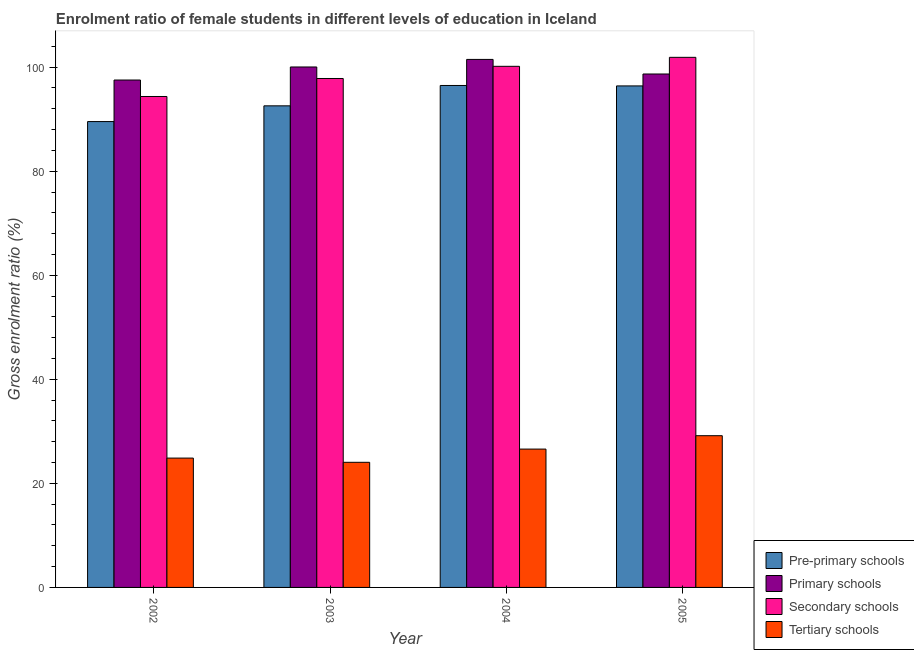How many different coloured bars are there?
Your answer should be very brief. 4. Are the number of bars on each tick of the X-axis equal?
Provide a short and direct response. Yes. How many bars are there on the 1st tick from the left?
Offer a terse response. 4. In how many cases, is the number of bars for a given year not equal to the number of legend labels?
Ensure brevity in your answer.  0. What is the gross enrolment ratio(male) in secondary schools in 2002?
Give a very brief answer. 94.36. Across all years, what is the maximum gross enrolment ratio(male) in pre-primary schools?
Give a very brief answer. 96.48. Across all years, what is the minimum gross enrolment ratio(male) in primary schools?
Your answer should be compact. 97.52. What is the total gross enrolment ratio(male) in secondary schools in the graph?
Offer a terse response. 394.22. What is the difference between the gross enrolment ratio(male) in tertiary schools in 2003 and that in 2004?
Your answer should be compact. -2.54. What is the difference between the gross enrolment ratio(male) in pre-primary schools in 2003 and the gross enrolment ratio(male) in secondary schools in 2002?
Offer a very short reply. 3.02. What is the average gross enrolment ratio(male) in primary schools per year?
Provide a succinct answer. 99.43. In the year 2002, what is the difference between the gross enrolment ratio(male) in primary schools and gross enrolment ratio(male) in tertiary schools?
Ensure brevity in your answer.  0. What is the ratio of the gross enrolment ratio(male) in secondary schools in 2002 to that in 2004?
Make the answer very short. 0.94. Is the difference between the gross enrolment ratio(male) in pre-primary schools in 2004 and 2005 greater than the difference between the gross enrolment ratio(male) in tertiary schools in 2004 and 2005?
Your answer should be compact. No. What is the difference between the highest and the second highest gross enrolment ratio(male) in pre-primary schools?
Keep it short and to the point. 0.09. What is the difference between the highest and the lowest gross enrolment ratio(male) in tertiary schools?
Your answer should be very brief. 5.11. Is it the case that in every year, the sum of the gross enrolment ratio(male) in tertiary schools and gross enrolment ratio(male) in secondary schools is greater than the sum of gross enrolment ratio(male) in pre-primary schools and gross enrolment ratio(male) in primary schools?
Provide a short and direct response. No. What does the 1st bar from the left in 2005 represents?
Offer a very short reply. Pre-primary schools. What does the 1st bar from the right in 2005 represents?
Give a very brief answer. Tertiary schools. Is it the case that in every year, the sum of the gross enrolment ratio(male) in pre-primary schools and gross enrolment ratio(male) in primary schools is greater than the gross enrolment ratio(male) in secondary schools?
Make the answer very short. Yes. How are the legend labels stacked?
Provide a short and direct response. Vertical. What is the title of the graph?
Provide a short and direct response. Enrolment ratio of female students in different levels of education in Iceland. Does "Structural Policies" appear as one of the legend labels in the graph?
Provide a short and direct response. No. What is the label or title of the X-axis?
Provide a succinct answer. Year. What is the Gross enrolment ratio (%) in Pre-primary schools in 2002?
Ensure brevity in your answer.  89.54. What is the Gross enrolment ratio (%) of Primary schools in 2002?
Ensure brevity in your answer.  97.52. What is the Gross enrolment ratio (%) of Secondary schools in 2002?
Offer a very short reply. 94.36. What is the Gross enrolment ratio (%) of Tertiary schools in 2002?
Ensure brevity in your answer.  24.86. What is the Gross enrolment ratio (%) in Pre-primary schools in 2003?
Offer a terse response. 92.56. What is the Gross enrolment ratio (%) of Primary schools in 2003?
Offer a very short reply. 100.03. What is the Gross enrolment ratio (%) in Secondary schools in 2003?
Offer a terse response. 97.82. What is the Gross enrolment ratio (%) in Tertiary schools in 2003?
Make the answer very short. 24.05. What is the Gross enrolment ratio (%) of Pre-primary schools in 2004?
Ensure brevity in your answer.  96.48. What is the Gross enrolment ratio (%) in Primary schools in 2004?
Your response must be concise. 101.49. What is the Gross enrolment ratio (%) in Secondary schools in 2004?
Your response must be concise. 100.16. What is the Gross enrolment ratio (%) of Tertiary schools in 2004?
Provide a succinct answer. 26.59. What is the Gross enrolment ratio (%) in Pre-primary schools in 2005?
Your answer should be very brief. 96.39. What is the Gross enrolment ratio (%) of Primary schools in 2005?
Offer a terse response. 98.68. What is the Gross enrolment ratio (%) of Secondary schools in 2005?
Your answer should be very brief. 101.89. What is the Gross enrolment ratio (%) in Tertiary schools in 2005?
Offer a very short reply. 29.16. Across all years, what is the maximum Gross enrolment ratio (%) of Pre-primary schools?
Keep it short and to the point. 96.48. Across all years, what is the maximum Gross enrolment ratio (%) of Primary schools?
Offer a very short reply. 101.49. Across all years, what is the maximum Gross enrolment ratio (%) of Secondary schools?
Give a very brief answer. 101.89. Across all years, what is the maximum Gross enrolment ratio (%) in Tertiary schools?
Offer a terse response. 29.16. Across all years, what is the minimum Gross enrolment ratio (%) in Pre-primary schools?
Provide a short and direct response. 89.54. Across all years, what is the minimum Gross enrolment ratio (%) of Primary schools?
Your response must be concise. 97.52. Across all years, what is the minimum Gross enrolment ratio (%) in Secondary schools?
Offer a terse response. 94.36. Across all years, what is the minimum Gross enrolment ratio (%) in Tertiary schools?
Offer a terse response. 24.05. What is the total Gross enrolment ratio (%) in Pre-primary schools in the graph?
Your response must be concise. 374.97. What is the total Gross enrolment ratio (%) of Primary schools in the graph?
Make the answer very short. 397.73. What is the total Gross enrolment ratio (%) in Secondary schools in the graph?
Offer a very short reply. 394.22. What is the total Gross enrolment ratio (%) in Tertiary schools in the graph?
Ensure brevity in your answer.  104.66. What is the difference between the Gross enrolment ratio (%) of Pre-primary schools in 2002 and that in 2003?
Provide a succinct answer. -3.02. What is the difference between the Gross enrolment ratio (%) of Primary schools in 2002 and that in 2003?
Your answer should be very brief. -2.51. What is the difference between the Gross enrolment ratio (%) of Secondary schools in 2002 and that in 2003?
Your answer should be very brief. -3.46. What is the difference between the Gross enrolment ratio (%) of Tertiary schools in 2002 and that in 2003?
Give a very brief answer. 0.81. What is the difference between the Gross enrolment ratio (%) of Pre-primary schools in 2002 and that in 2004?
Offer a very short reply. -6.94. What is the difference between the Gross enrolment ratio (%) of Primary schools in 2002 and that in 2004?
Give a very brief answer. -3.96. What is the difference between the Gross enrolment ratio (%) of Secondary schools in 2002 and that in 2004?
Provide a short and direct response. -5.8. What is the difference between the Gross enrolment ratio (%) of Tertiary schools in 2002 and that in 2004?
Offer a very short reply. -1.73. What is the difference between the Gross enrolment ratio (%) in Pre-primary schools in 2002 and that in 2005?
Offer a very short reply. -6.85. What is the difference between the Gross enrolment ratio (%) in Primary schools in 2002 and that in 2005?
Your answer should be compact. -1.16. What is the difference between the Gross enrolment ratio (%) of Secondary schools in 2002 and that in 2005?
Offer a very short reply. -7.53. What is the difference between the Gross enrolment ratio (%) of Tertiary schools in 2002 and that in 2005?
Provide a short and direct response. -4.3. What is the difference between the Gross enrolment ratio (%) in Pre-primary schools in 2003 and that in 2004?
Ensure brevity in your answer.  -3.92. What is the difference between the Gross enrolment ratio (%) in Primary schools in 2003 and that in 2004?
Provide a succinct answer. -1.46. What is the difference between the Gross enrolment ratio (%) of Secondary schools in 2003 and that in 2004?
Keep it short and to the point. -2.34. What is the difference between the Gross enrolment ratio (%) in Tertiary schools in 2003 and that in 2004?
Make the answer very short. -2.54. What is the difference between the Gross enrolment ratio (%) in Pre-primary schools in 2003 and that in 2005?
Offer a terse response. -3.83. What is the difference between the Gross enrolment ratio (%) in Primary schools in 2003 and that in 2005?
Provide a short and direct response. 1.35. What is the difference between the Gross enrolment ratio (%) in Secondary schools in 2003 and that in 2005?
Your answer should be compact. -4.07. What is the difference between the Gross enrolment ratio (%) of Tertiary schools in 2003 and that in 2005?
Offer a very short reply. -5.11. What is the difference between the Gross enrolment ratio (%) in Pre-primary schools in 2004 and that in 2005?
Your response must be concise. 0.09. What is the difference between the Gross enrolment ratio (%) in Primary schools in 2004 and that in 2005?
Ensure brevity in your answer.  2.8. What is the difference between the Gross enrolment ratio (%) in Secondary schools in 2004 and that in 2005?
Your response must be concise. -1.73. What is the difference between the Gross enrolment ratio (%) of Tertiary schools in 2004 and that in 2005?
Offer a very short reply. -2.57. What is the difference between the Gross enrolment ratio (%) of Pre-primary schools in 2002 and the Gross enrolment ratio (%) of Primary schools in 2003?
Keep it short and to the point. -10.49. What is the difference between the Gross enrolment ratio (%) of Pre-primary schools in 2002 and the Gross enrolment ratio (%) of Secondary schools in 2003?
Your answer should be very brief. -8.28. What is the difference between the Gross enrolment ratio (%) in Pre-primary schools in 2002 and the Gross enrolment ratio (%) in Tertiary schools in 2003?
Keep it short and to the point. 65.49. What is the difference between the Gross enrolment ratio (%) of Primary schools in 2002 and the Gross enrolment ratio (%) of Secondary schools in 2003?
Provide a short and direct response. -0.3. What is the difference between the Gross enrolment ratio (%) of Primary schools in 2002 and the Gross enrolment ratio (%) of Tertiary schools in 2003?
Offer a terse response. 73.47. What is the difference between the Gross enrolment ratio (%) in Secondary schools in 2002 and the Gross enrolment ratio (%) in Tertiary schools in 2003?
Provide a short and direct response. 70.31. What is the difference between the Gross enrolment ratio (%) of Pre-primary schools in 2002 and the Gross enrolment ratio (%) of Primary schools in 2004?
Provide a succinct answer. -11.95. What is the difference between the Gross enrolment ratio (%) of Pre-primary schools in 2002 and the Gross enrolment ratio (%) of Secondary schools in 2004?
Provide a succinct answer. -10.62. What is the difference between the Gross enrolment ratio (%) in Pre-primary schools in 2002 and the Gross enrolment ratio (%) in Tertiary schools in 2004?
Provide a short and direct response. 62.95. What is the difference between the Gross enrolment ratio (%) in Primary schools in 2002 and the Gross enrolment ratio (%) in Secondary schools in 2004?
Your response must be concise. -2.64. What is the difference between the Gross enrolment ratio (%) in Primary schools in 2002 and the Gross enrolment ratio (%) in Tertiary schools in 2004?
Your answer should be compact. 70.93. What is the difference between the Gross enrolment ratio (%) in Secondary schools in 2002 and the Gross enrolment ratio (%) in Tertiary schools in 2004?
Your answer should be very brief. 67.77. What is the difference between the Gross enrolment ratio (%) of Pre-primary schools in 2002 and the Gross enrolment ratio (%) of Primary schools in 2005?
Give a very brief answer. -9.14. What is the difference between the Gross enrolment ratio (%) of Pre-primary schools in 2002 and the Gross enrolment ratio (%) of Secondary schools in 2005?
Keep it short and to the point. -12.35. What is the difference between the Gross enrolment ratio (%) of Pre-primary schools in 2002 and the Gross enrolment ratio (%) of Tertiary schools in 2005?
Give a very brief answer. 60.38. What is the difference between the Gross enrolment ratio (%) in Primary schools in 2002 and the Gross enrolment ratio (%) in Secondary schools in 2005?
Give a very brief answer. -4.36. What is the difference between the Gross enrolment ratio (%) of Primary schools in 2002 and the Gross enrolment ratio (%) of Tertiary schools in 2005?
Offer a terse response. 68.36. What is the difference between the Gross enrolment ratio (%) of Secondary schools in 2002 and the Gross enrolment ratio (%) of Tertiary schools in 2005?
Provide a short and direct response. 65.2. What is the difference between the Gross enrolment ratio (%) of Pre-primary schools in 2003 and the Gross enrolment ratio (%) of Primary schools in 2004?
Make the answer very short. -8.92. What is the difference between the Gross enrolment ratio (%) in Pre-primary schools in 2003 and the Gross enrolment ratio (%) in Secondary schools in 2004?
Your response must be concise. -7.6. What is the difference between the Gross enrolment ratio (%) of Pre-primary schools in 2003 and the Gross enrolment ratio (%) of Tertiary schools in 2004?
Your response must be concise. 65.97. What is the difference between the Gross enrolment ratio (%) of Primary schools in 2003 and the Gross enrolment ratio (%) of Secondary schools in 2004?
Provide a succinct answer. -0.13. What is the difference between the Gross enrolment ratio (%) of Primary schools in 2003 and the Gross enrolment ratio (%) of Tertiary schools in 2004?
Ensure brevity in your answer.  73.44. What is the difference between the Gross enrolment ratio (%) in Secondary schools in 2003 and the Gross enrolment ratio (%) in Tertiary schools in 2004?
Offer a very short reply. 71.23. What is the difference between the Gross enrolment ratio (%) in Pre-primary schools in 2003 and the Gross enrolment ratio (%) in Primary schools in 2005?
Your answer should be compact. -6.12. What is the difference between the Gross enrolment ratio (%) in Pre-primary schools in 2003 and the Gross enrolment ratio (%) in Secondary schools in 2005?
Your answer should be very brief. -9.32. What is the difference between the Gross enrolment ratio (%) of Pre-primary schools in 2003 and the Gross enrolment ratio (%) of Tertiary schools in 2005?
Keep it short and to the point. 63.4. What is the difference between the Gross enrolment ratio (%) in Primary schools in 2003 and the Gross enrolment ratio (%) in Secondary schools in 2005?
Give a very brief answer. -1.85. What is the difference between the Gross enrolment ratio (%) of Primary schools in 2003 and the Gross enrolment ratio (%) of Tertiary schools in 2005?
Your response must be concise. 70.87. What is the difference between the Gross enrolment ratio (%) in Secondary schools in 2003 and the Gross enrolment ratio (%) in Tertiary schools in 2005?
Provide a succinct answer. 68.66. What is the difference between the Gross enrolment ratio (%) in Pre-primary schools in 2004 and the Gross enrolment ratio (%) in Primary schools in 2005?
Your answer should be very brief. -2.21. What is the difference between the Gross enrolment ratio (%) in Pre-primary schools in 2004 and the Gross enrolment ratio (%) in Secondary schools in 2005?
Keep it short and to the point. -5.41. What is the difference between the Gross enrolment ratio (%) in Pre-primary schools in 2004 and the Gross enrolment ratio (%) in Tertiary schools in 2005?
Give a very brief answer. 67.32. What is the difference between the Gross enrolment ratio (%) in Primary schools in 2004 and the Gross enrolment ratio (%) in Secondary schools in 2005?
Offer a terse response. -0.4. What is the difference between the Gross enrolment ratio (%) in Primary schools in 2004 and the Gross enrolment ratio (%) in Tertiary schools in 2005?
Your answer should be compact. 72.33. What is the difference between the Gross enrolment ratio (%) in Secondary schools in 2004 and the Gross enrolment ratio (%) in Tertiary schools in 2005?
Offer a very short reply. 71. What is the average Gross enrolment ratio (%) of Pre-primary schools per year?
Give a very brief answer. 93.74. What is the average Gross enrolment ratio (%) in Primary schools per year?
Ensure brevity in your answer.  99.43. What is the average Gross enrolment ratio (%) in Secondary schools per year?
Keep it short and to the point. 98.56. What is the average Gross enrolment ratio (%) of Tertiary schools per year?
Make the answer very short. 26.17. In the year 2002, what is the difference between the Gross enrolment ratio (%) of Pre-primary schools and Gross enrolment ratio (%) of Primary schools?
Give a very brief answer. -7.98. In the year 2002, what is the difference between the Gross enrolment ratio (%) in Pre-primary schools and Gross enrolment ratio (%) in Secondary schools?
Provide a short and direct response. -4.82. In the year 2002, what is the difference between the Gross enrolment ratio (%) in Pre-primary schools and Gross enrolment ratio (%) in Tertiary schools?
Your answer should be very brief. 64.68. In the year 2002, what is the difference between the Gross enrolment ratio (%) in Primary schools and Gross enrolment ratio (%) in Secondary schools?
Your response must be concise. 3.17. In the year 2002, what is the difference between the Gross enrolment ratio (%) of Primary schools and Gross enrolment ratio (%) of Tertiary schools?
Offer a terse response. 72.66. In the year 2002, what is the difference between the Gross enrolment ratio (%) of Secondary schools and Gross enrolment ratio (%) of Tertiary schools?
Your answer should be very brief. 69.5. In the year 2003, what is the difference between the Gross enrolment ratio (%) in Pre-primary schools and Gross enrolment ratio (%) in Primary schools?
Keep it short and to the point. -7.47. In the year 2003, what is the difference between the Gross enrolment ratio (%) of Pre-primary schools and Gross enrolment ratio (%) of Secondary schools?
Give a very brief answer. -5.26. In the year 2003, what is the difference between the Gross enrolment ratio (%) of Pre-primary schools and Gross enrolment ratio (%) of Tertiary schools?
Your answer should be compact. 68.51. In the year 2003, what is the difference between the Gross enrolment ratio (%) of Primary schools and Gross enrolment ratio (%) of Secondary schools?
Make the answer very short. 2.21. In the year 2003, what is the difference between the Gross enrolment ratio (%) in Primary schools and Gross enrolment ratio (%) in Tertiary schools?
Your response must be concise. 75.98. In the year 2003, what is the difference between the Gross enrolment ratio (%) of Secondary schools and Gross enrolment ratio (%) of Tertiary schools?
Your response must be concise. 73.77. In the year 2004, what is the difference between the Gross enrolment ratio (%) of Pre-primary schools and Gross enrolment ratio (%) of Primary schools?
Provide a succinct answer. -5.01. In the year 2004, what is the difference between the Gross enrolment ratio (%) in Pre-primary schools and Gross enrolment ratio (%) in Secondary schools?
Ensure brevity in your answer.  -3.68. In the year 2004, what is the difference between the Gross enrolment ratio (%) in Pre-primary schools and Gross enrolment ratio (%) in Tertiary schools?
Provide a short and direct response. 69.89. In the year 2004, what is the difference between the Gross enrolment ratio (%) of Primary schools and Gross enrolment ratio (%) of Secondary schools?
Your answer should be very brief. 1.33. In the year 2004, what is the difference between the Gross enrolment ratio (%) in Primary schools and Gross enrolment ratio (%) in Tertiary schools?
Give a very brief answer. 74.9. In the year 2004, what is the difference between the Gross enrolment ratio (%) of Secondary schools and Gross enrolment ratio (%) of Tertiary schools?
Provide a short and direct response. 73.57. In the year 2005, what is the difference between the Gross enrolment ratio (%) of Pre-primary schools and Gross enrolment ratio (%) of Primary schools?
Give a very brief answer. -2.29. In the year 2005, what is the difference between the Gross enrolment ratio (%) of Pre-primary schools and Gross enrolment ratio (%) of Secondary schools?
Give a very brief answer. -5.49. In the year 2005, what is the difference between the Gross enrolment ratio (%) of Pre-primary schools and Gross enrolment ratio (%) of Tertiary schools?
Ensure brevity in your answer.  67.23. In the year 2005, what is the difference between the Gross enrolment ratio (%) of Primary schools and Gross enrolment ratio (%) of Secondary schools?
Make the answer very short. -3.2. In the year 2005, what is the difference between the Gross enrolment ratio (%) in Primary schools and Gross enrolment ratio (%) in Tertiary schools?
Ensure brevity in your answer.  69.52. In the year 2005, what is the difference between the Gross enrolment ratio (%) of Secondary schools and Gross enrolment ratio (%) of Tertiary schools?
Make the answer very short. 72.72. What is the ratio of the Gross enrolment ratio (%) of Pre-primary schools in 2002 to that in 2003?
Provide a succinct answer. 0.97. What is the ratio of the Gross enrolment ratio (%) of Primary schools in 2002 to that in 2003?
Provide a short and direct response. 0.97. What is the ratio of the Gross enrolment ratio (%) of Secondary schools in 2002 to that in 2003?
Your answer should be very brief. 0.96. What is the ratio of the Gross enrolment ratio (%) in Tertiary schools in 2002 to that in 2003?
Provide a short and direct response. 1.03. What is the ratio of the Gross enrolment ratio (%) in Pre-primary schools in 2002 to that in 2004?
Your response must be concise. 0.93. What is the ratio of the Gross enrolment ratio (%) of Primary schools in 2002 to that in 2004?
Offer a terse response. 0.96. What is the ratio of the Gross enrolment ratio (%) in Secondary schools in 2002 to that in 2004?
Offer a terse response. 0.94. What is the ratio of the Gross enrolment ratio (%) of Tertiary schools in 2002 to that in 2004?
Provide a succinct answer. 0.93. What is the ratio of the Gross enrolment ratio (%) in Pre-primary schools in 2002 to that in 2005?
Give a very brief answer. 0.93. What is the ratio of the Gross enrolment ratio (%) in Primary schools in 2002 to that in 2005?
Your answer should be compact. 0.99. What is the ratio of the Gross enrolment ratio (%) of Secondary schools in 2002 to that in 2005?
Ensure brevity in your answer.  0.93. What is the ratio of the Gross enrolment ratio (%) of Tertiary schools in 2002 to that in 2005?
Provide a succinct answer. 0.85. What is the ratio of the Gross enrolment ratio (%) in Pre-primary schools in 2003 to that in 2004?
Your answer should be very brief. 0.96. What is the ratio of the Gross enrolment ratio (%) of Primary schools in 2003 to that in 2004?
Give a very brief answer. 0.99. What is the ratio of the Gross enrolment ratio (%) of Secondary schools in 2003 to that in 2004?
Provide a short and direct response. 0.98. What is the ratio of the Gross enrolment ratio (%) of Tertiary schools in 2003 to that in 2004?
Give a very brief answer. 0.9. What is the ratio of the Gross enrolment ratio (%) in Pre-primary schools in 2003 to that in 2005?
Give a very brief answer. 0.96. What is the ratio of the Gross enrolment ratio (%) in Primary schools in 2003 to that in 2005?
Give a very brief answer. 1.01. What is the ratio of the Gross enrolment ratio (%) in Secondary schools in 2003 to that in 2005?
Offer a terse response. 0.96. What is the ratio of the Gross enrolment ratio (%) in Tertiary schools in 2003 to that in 2005?
Your answer should be very brief. 0.82. What is the ratio of the Gross enrolment ratio (%) of Primary schools in 2004 to that in 2005?
Make the answer very short. 1.03. What is the ratio of the Gross enrolment ratio (%) in Secondary schools in 2004 to that in 2005?
Your answer should be very brief. 0.98. What is the ratio of the Gross enrolment ratio (%) of Tertiary schools in 2004 to that in 2005?
Your answer should be very brief. 0.91. What is the difference between the highest and the second highest Gross enrolment ratio (%) in Pre-primary schools?
Provide a short and direct response. 0.09. What is the difference between the highest and the second highest Gross enrolment ratio (%) in Primary schools?
Make the answer very short. 1.46. What is the difference between the highest and the second highest Gross enrolment ratio (%) in Secondary schools?
Give a very brief answer. 1.73. What is the difference between the highest and the second highest Gross enrolment ratio (%) of Tertiary schools?
Offer a terse response. 2.57. What is the difference between the highest and the lowest Gross enrolment ratio (%) in Pre-primary schools?
Offer a very short reply. 6.94. What is the difference between the highest and the lowest Gross enrolment ratio (%) of Primary schools?
Your response must be concise. 3.96. What is the difference between the highest and the lowest Gross enrolment ratio (%) of Secondary schools?
Give a very brief answer. 7.53. What is the difference between the highest and the lowest Gross enrolment ratio (%) of Tertiary schools?
Give a very brief answer. 5.11. 